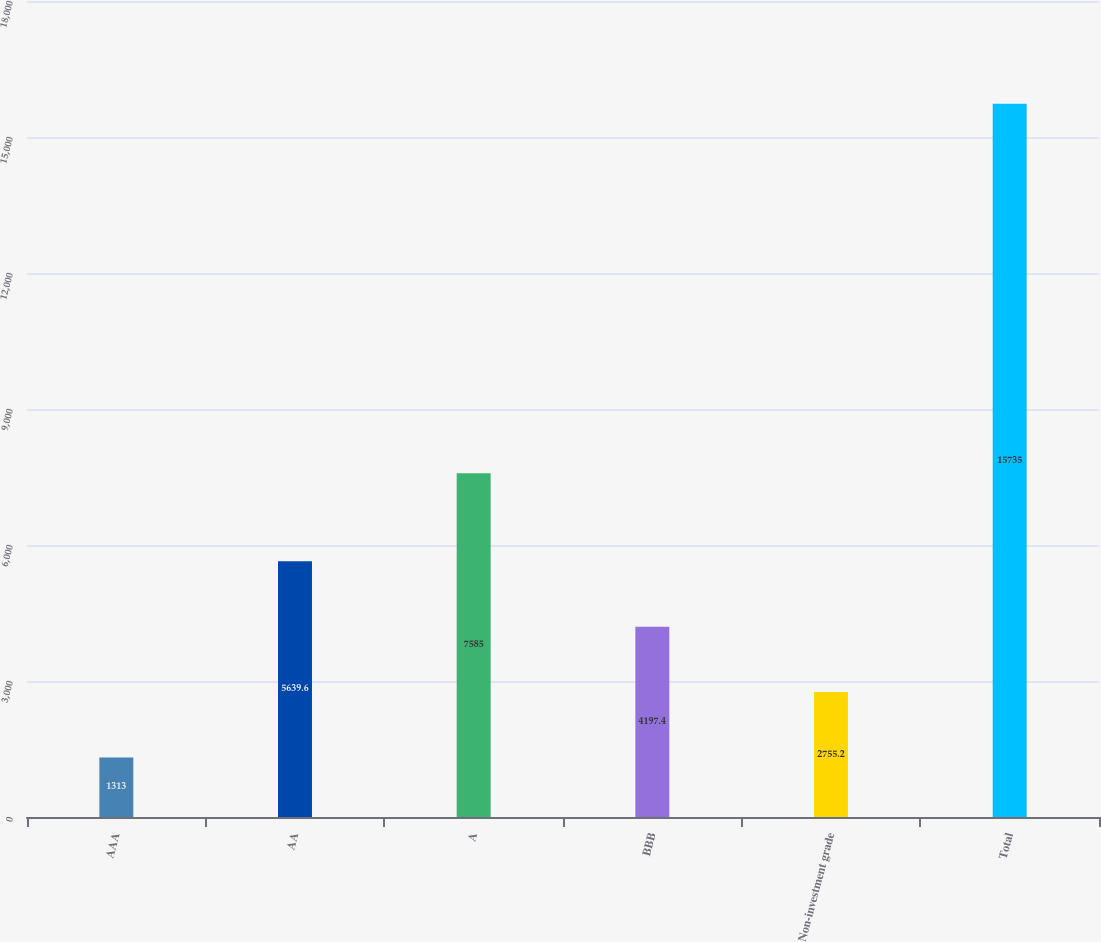<chart> <loc_0><loc_0><loc_500><loc_500><bar_chart><fcel>AAA<fcel>AA<fcel>A<fcel>BBB<fcel>Non-investment grade<fcel>Total<nl><fcel>1313<fcel>5639.6<fcel>7585<fcel>4197.4<fcel>2755.2<fcel>15735<nl></chart> 